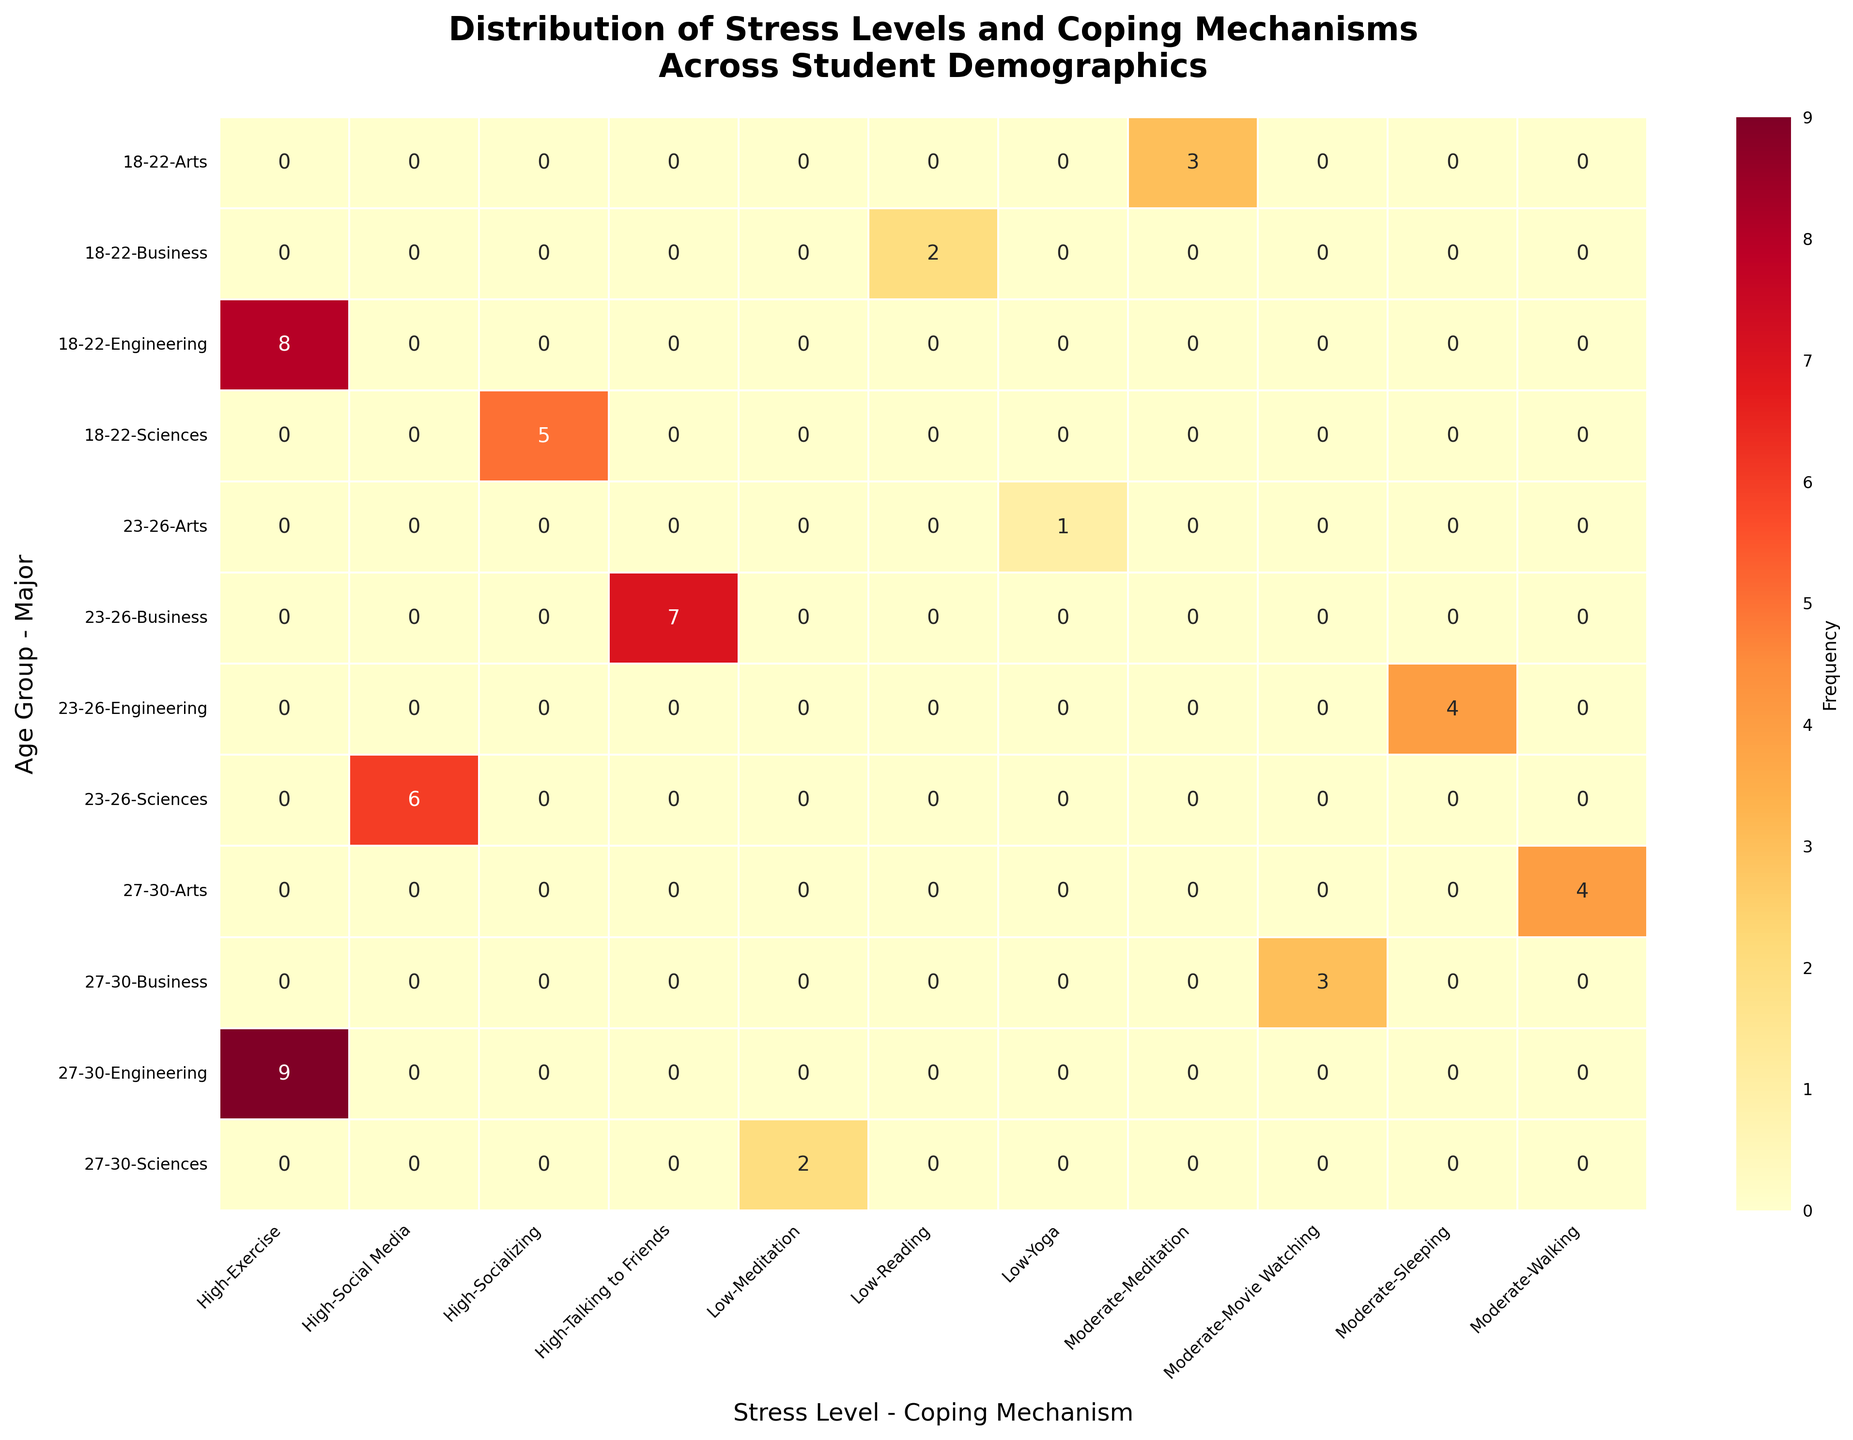What is the title of the heatmap? The title of the heatmap is displayed at the top of the figure.
Answer: Distribution of Stress Levels and Coping Mechanisms Across Student Demographics How many unique age groups are represented in the heatmap? The unique age groups can be determined by looking at the y-axis labels. The age groups are separated by dashed lines.
Answer: 3 Which coping mechanism is most frequently used by Engineering students aged 27-30 for high stress levels? By intersecting the '27-30, Engineering, High' row with the appropriate column for coping mechanisms, we see the highlighted cell with the highest frequency value.
Answer: Exercise What is the total frequency of students aged 18-22 in the Sciences major with any stress level? Add the values of the cells corresponding to 18-22, Sciences across all stress levels and coping mechanisms shown.
Answer: 5 (High, Socializing) Which student group uses Meditation as a coping mechanism and what is their stress level? Locate the column with Meditation as a Coping Mechanism and identify the intersecting cells to find the stress level and demographic information.
Answer: 18-22, Arts, Moderate; 27-30, Sciences, Low How does the frequency of students aged 23-26 in Business dealing with high stress compare to those in the same age group but in Sciences? Compare the values of the cells corresponding to '23-26, Business, High' and '23-26, Sciences, High'.
Answer: Business: 7, Sciences: 6 What is the least common stress level among 18-22 year-olds across all majors? Sum the frequencies of each stress level for all majors within the 18-22 age group and compare them.
Answer: Low (2) Comparing the frequency of Engineering students using Exercise and Socializing as coping mechanisms, which one is more commonly used and in which age group? Locate the cells for 'Exercise' and 'Socializing' under Engineering across all age groups and compare their frequencies.
Answer: Exercise, 27-30 What is the most common combination of stress level and coping mechanism across all age groups and majors? Identify the cell with the highest frequency value in the heatmap and read off its corresponding stress level and coping mechanism.
Answer: High Stress, Exercise (27-30, Engineering) What is the combined frequency of students aged 23-26 in Sciences and Business experiencing high stress? Sum the frequencies of cells '23-26, Sciences, High' and '23-26, Business, High'.
Answer: 13 